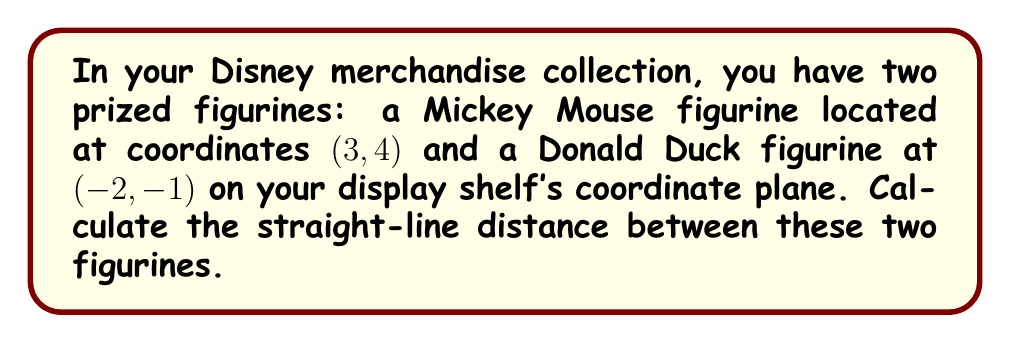Show me your answer to this math problem. To find the distance between two points on a coordinate plane, we use the distance formula, which is derived from the Pythagorean theorem:

$$d = \sqrt{(x_2 - x_1)^2 + (y_2 - y_1)^2}$$

Where $(x_1, y_1)$ is the coordinate of the first point and $(x_2, y_2)$ is the coordinate of the second point.

Let's assign our points:
Mickey Mouse: $(x_1, y_1) = (3, 4)$
Donald Duck: $(x_2, y_2) = (-2, -1)$

Now, let's substitute these values into the formula:

$$\begin{align*}
d &= \sqrt{(-2 - 3)^2 + (-1 - 4)^2} \\
&= \sqrt{(-5)^2 + (-5)^2} \\
&= \sqrt{25 + 25} \\
&= \sqrt{50} \\
&= 5\sqrt{2}
\end{align*}$$

Therefore, the distance between the Mickey Mouse and Donald Duck figurines is $5\sqrt{2}$ units.

[asy]
unitsize(1cm);
dot((3,4));
dot((-2,-1));
draw((3,4)--(-2,-1), arrow=Arrow(TeXHead));
label("Mickey (3, 4)", (3,4), NE);
label("Donald (-2, -1)", (-2,-1), SW);
label("$5\sqrt{2}$", (0.5,1.5), NW);
[/asy]
Answer: $5\sqrt{2}$ units 